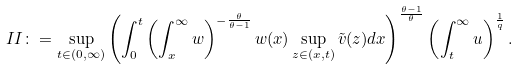Convert formula to latex. <formula><loc_0><loc_0><loc_500><loc_500>I I \colon = \sup _ { t \in ( 0 , \infty ) } \left ( \int _ { 0 } ^ { t } \left ( \int _ { x } ^ { \infty } w \right ) ^ { - \frac { \theta } { \theta - 1 } } w ( x ) \sup _ { z \in ( x , t ) } \tilde { v } ( z ) d x \right ) ^ { \frac { \theta - 1 } { \theta } } \left ( \int _ { t } ^ { \infty } u \right ) ^ { \frac { 1 } { q } } .</formula> 